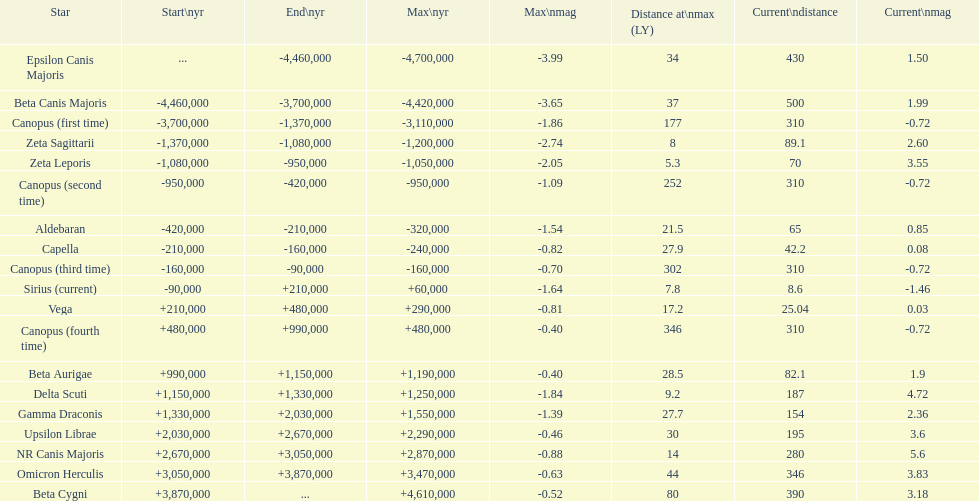How many stars have a magnitude greater than zero? 14. 